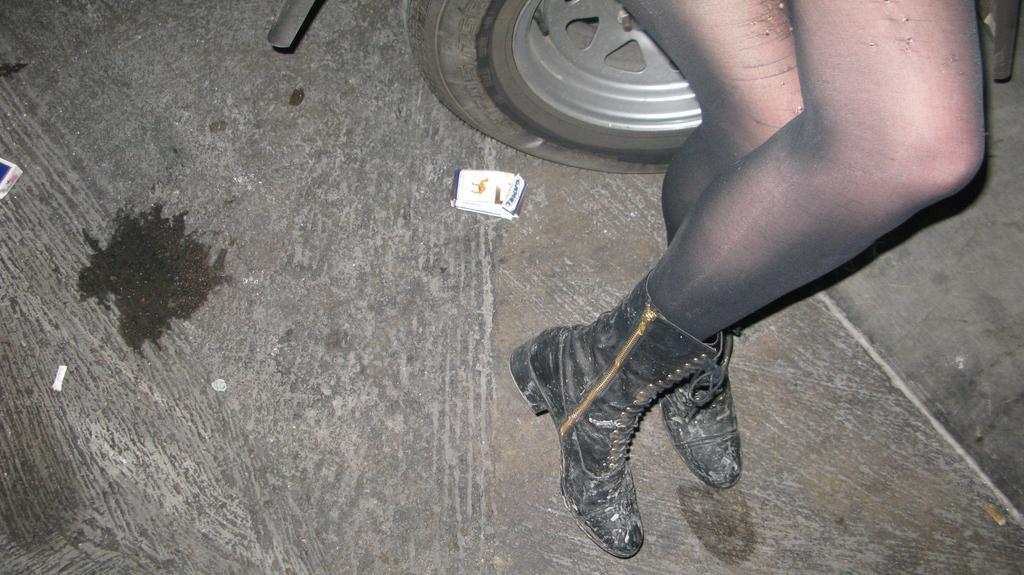Please provide a concise description of this image. In this picture there is a woman who is wearing black shoe. She is standing near to the car. At the top we can see the cars, beside that there is a cigarette packet on the floor. 